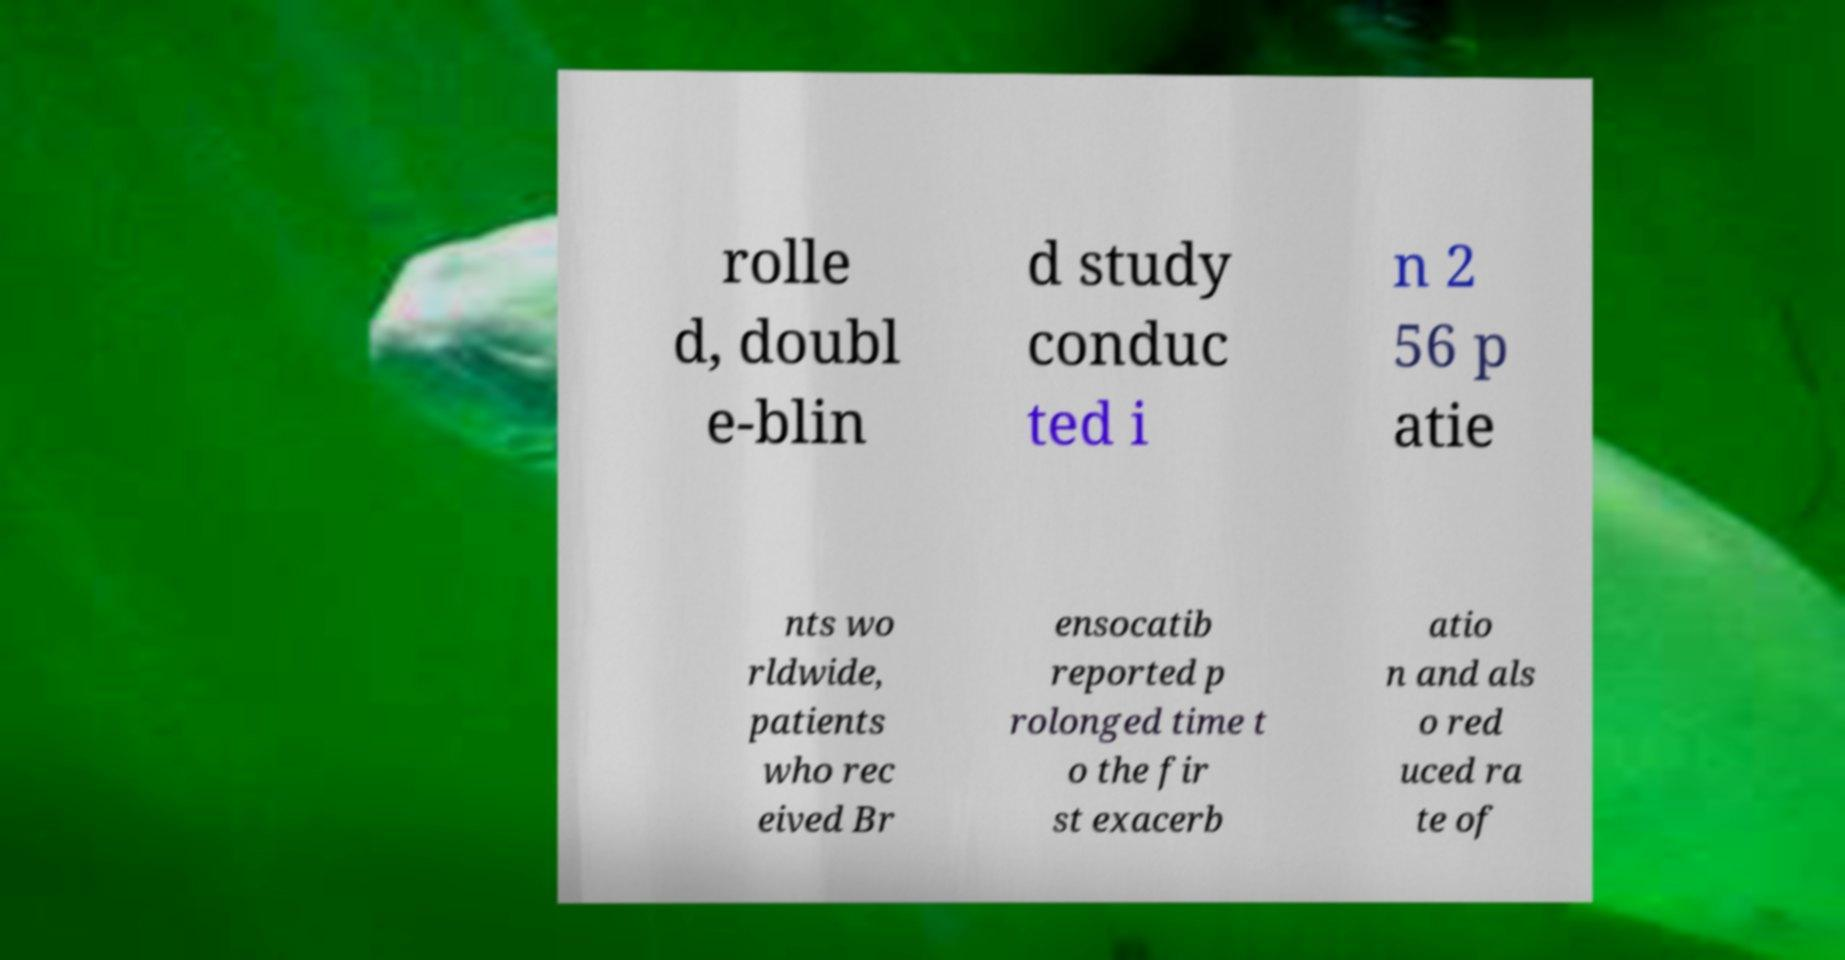Can you accurately transcribe the text from the provided image for me? rolle d, doubl e-blin d study conduc ted i n 2 56 p atie nts wo rldwide, patients who rec eived Br ensocatib reported p rolonged time t o the fir st exacerb atio n and als o red uced ra te of 